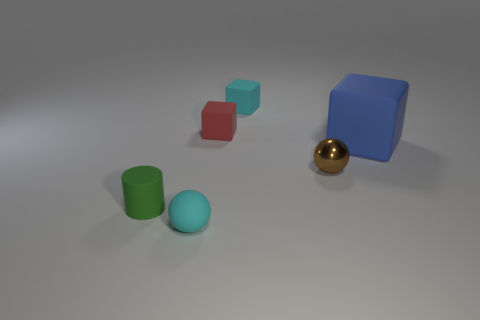Are there any other things that have the same size as the blue rubber object?
Give a very brief answer. No. There is a small object that is the same color as the small matte sphere; what material is it?
Ensure brevity in your answer.  Rubber. What number of shiny things are either small yellow cubes or brown spheres?
Ensure brevity in your answer.  1. There is a blue rubber thing; what shape is it?
Offer a terse response. Cube. What number of large yellow cubes have the same material as the big blue cube?
Give a very brief answer. 0. What is the color of the large thing that is made of the same material as the small green cylinder?
Offer a very short reply. Blue. There is a cyan rubber thing behind the cyan sphere; is it the same size as the red rubber block?
Offer a very short reply. Yes. What is the color of the other thing that is the same shape as the small brown metallic thing?
Provide a short and direct response. Cyan. What is the shape of the rubber object that is on the right side of the tiny cyan object right of the cyan thing in front of the green thing?
Give a very brief answer. Cube. Is the tiny brown shiny object the same shape as the big thing?
Give a very brief answer. No. 